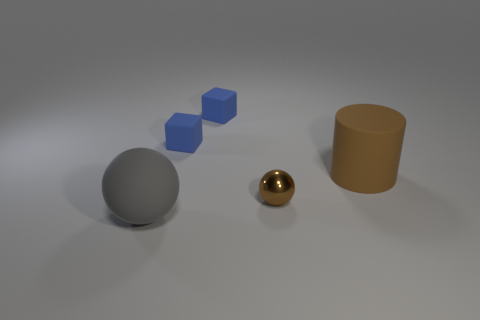Add 5 large gray matte objects. How many objects exist? 10 Subtract all blocks. How many objects are left? 3 Add 2 brown things. How many brown things exist? 4 Subtract 0 yellow spheres. How many objects are left? 5 Subtract all yellow rubber cylinders. Subtract all gray rubber objects. How many objects are left? 4 Add 4 blue rubber blocks. How many blue rubber blocks are left? 6 